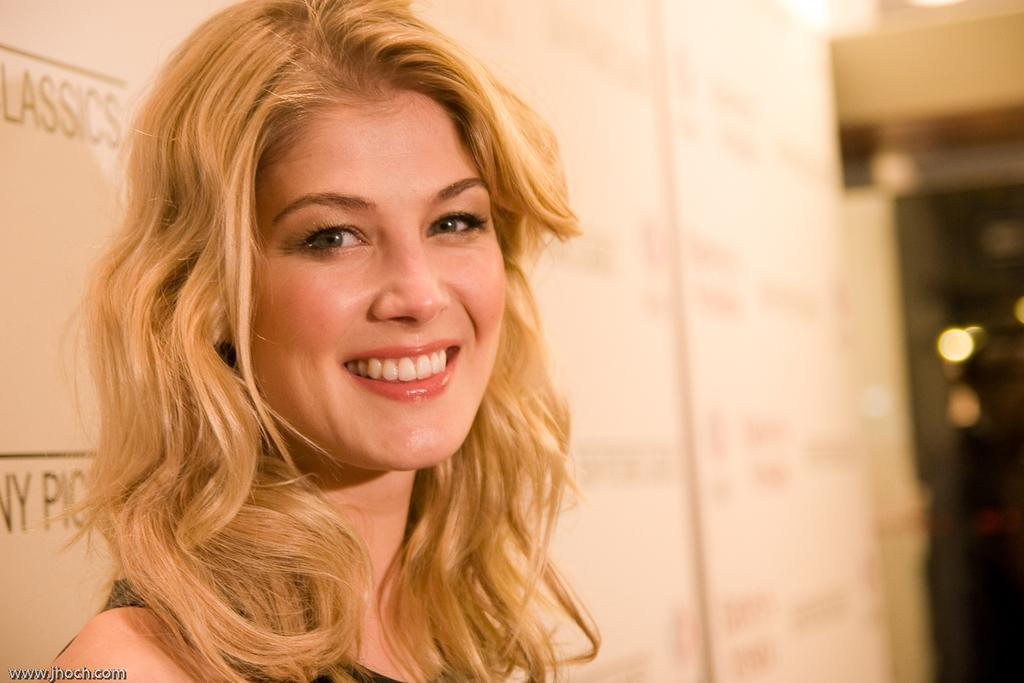Who is present in the image? There is a woman in the image. What is the woman's expression? The woman is smiling. What can be seen in the background of the image? There are white color banners with text in the background of the image. What type of fear does the woman have in the image? There is no indication of fear in the image; the woman is smiling. What cast member can be seen in the image? There is no reference to a cast or any specific individuals in the image. 